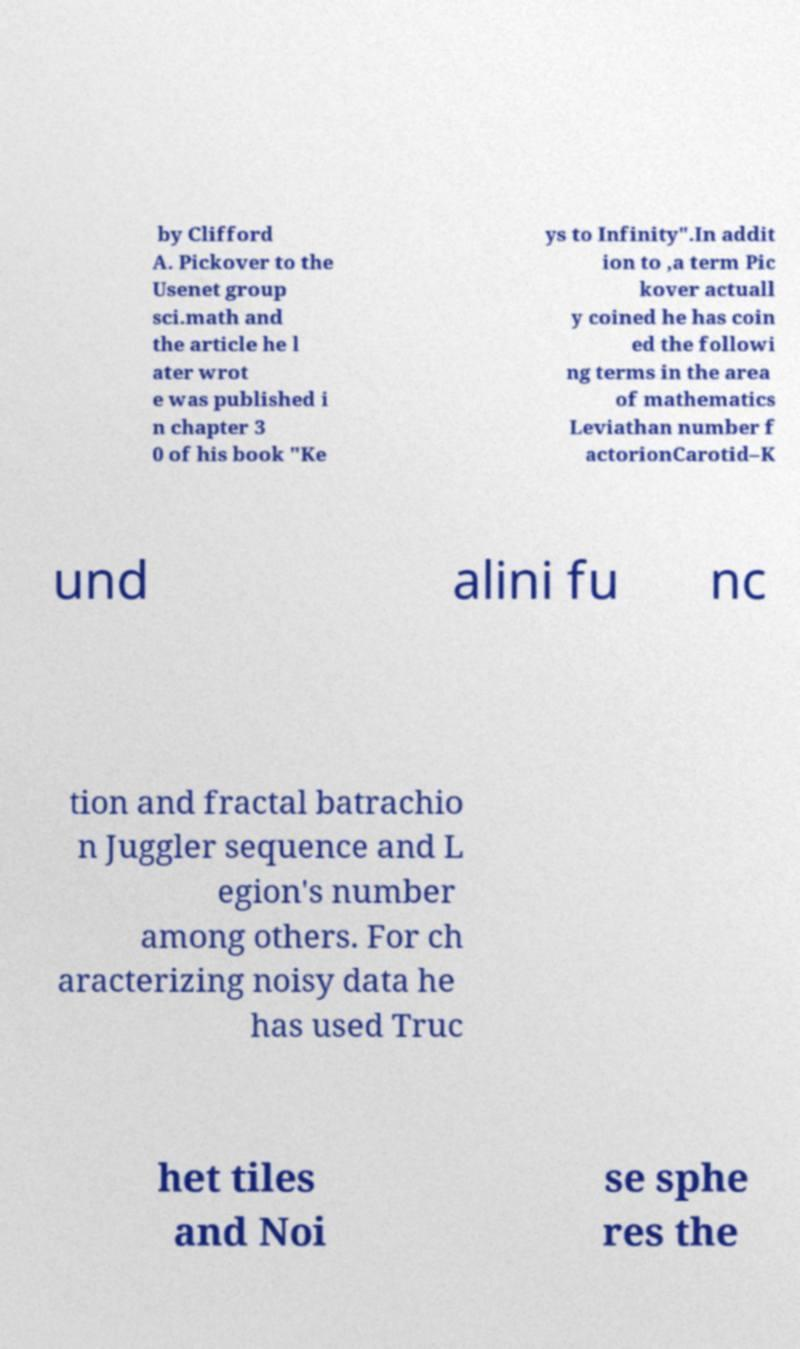There's text embedded in this image that I need extracted. Can you transcribe it verbatim? by Clifford A. Pickover to the Usenet group sci.math and the article he l ater wrot e was published i n chapter 3 0 of his book "Ke ys to Infinity".In addit ion to ,a term Pic kover actuall y coined he has coin ed the followi ng terms in the area of mathematics Leviathan number f actorionCarotid–K und alini fu nc tion and fractal batrachio n Juggler sequence and L egion's number among others. For ch aracterizing noisy data he has used Truc het tiles and Noi se sphe res the 